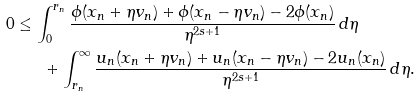Convert formula to latex. <formula><loc_0><loc_0><loc_500><loc_500>0 & \leq \int _ { 0 } ^ { r _ { n } } \frac { \phi ( x _ { n } + \eta v _ { n } ) + \phi ( x _ { n } - \eta v _ { n } ) - 2 \phi ( x _ { n } ) } { \eta ^ { 2 s + 1 } } \, d \eta \\ & \quad \ \ + \int _ { r _ { n } } ^ { \infty } \frac { u _ { n } ( x _ { n } + \eta v _ { n } ) + u _ { n } ( x _ { n } - \eta v _ { n } ) - 2 u _ { n } ( x _ { n } ) } { \eta ^ { 2 s + 1 } } \, d \eta .</formula> 